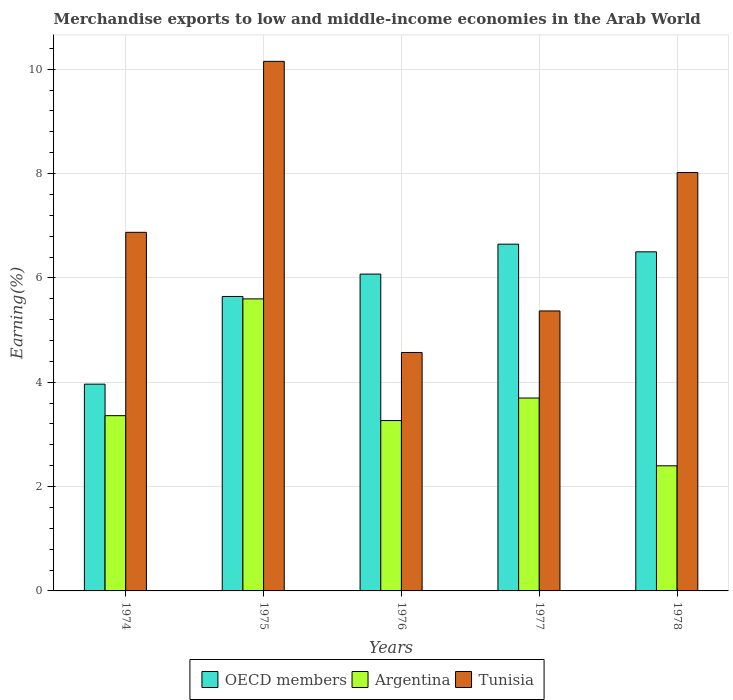How many groups of bars are there?
Your answer should be compact. 5. Are the number of bars on each tick of the X-axis equal?
Provide a short and direct response. Yes. How many bars are there on the 4th tick from the left?
Give a very brief answer. 3. What is the label of the 5th group of bars from the left?
Make the answer very short. 1978. What is the percentage of amount earned from merchandise exports in Argentina in 1977?
Your answer should be very brief. 3.7. Across all years, what is the maximum percentage of amount earned from merchandise exports in Argentina?
Your answer should be compact. 5.6. Across all years, what is the minimum percentage of amount earned from merchandise exports in OECD members?
Your answer should be very brief. 3.96. In which year was the percentage of amount earned from merchandise exports in Tunisia maximum?
Your answer should be compact. 1975. In which year was the percentage of amount earned from merchandise exports in Tunisia minimum?
Offer a very short reply. 1976. What is the total percentage of amount earned from merchandise exports in Tunisia in the graph?
Your answer should be compact. 34.98. What is the difference between the percentage of amount earned from merchandise exports in Argentina in 1977 and that in 1978?
Provide a succinct answer. 1.3. What is the difference between the percentage of amount earned from merchandise exports in OECD members in 1977 and the percentage of amount earned from merchandise exports in Argentina in 1976?
Provide a short and direct response. 3.38. What is the average percentage of amount earned from merchandise exports in Argentina per year?
Provide a short and direct response. 3.66. In the year 1977, what is the difference between the percentage of amount earned from merchandise exports in Argentina and percentage of amount earned from merchandise exports in OECD members?
Your response must be concise. -2.95. What is the ratio of the percentage of amount earned from merchandise exports in Argentina in 1974 to that in 1978?
Make the answer very short. 1.4. Is the percentage of amount earned from merchandise exports in Argentina in 1976 less than that in 1978?
Offer a terse response. No. What is the difference between the highest and the second highest percentage of amount earned from merchandise exports in Argentina?
Keep it short and to the point. 1.9. What is the difference between the highest and the lowest percentage of amount earned from merchandise exports in OECD members?
Offer a very short reply. 2.68. What does the 2nd bar from the left in 1978 represents?
Make the answer very short. Argentina. How many years are there in the graph?
Offer a very short reply. 5. Are the values on the major ticks of Y-axis written in scientific E-notation?
Your response must be concise. No. Does the graph contain grids?
Offer a terse response. Yes. How are the legend labels stacked?
Provide a short and direct response. Horizontal. What is the title of the graph?
Provide a short and direct response. Merchandise exports to low and middle-income economies in the Arab World. Does "Aruba" appear as one of the legend labels in the graph?
Keep it short and to the point. No. What is the label or title of the X-axis?
Your response must be concise. Years. What is the label or title of the Y-axis?
Your answer should be very brief. Earning(%). What is the Earning(%) in OECD members in 1974?
Your answer should be compact. 3.96. What is the Earning(%) of Argentina in 1974?
Provide a succinct answer. 3.36. What is the Earning(%) of Tunisia in 1974?
Ensure brevity in your answer.  6.87. What is the Earning(%) in OECD members in 1975?
Your answer should be compact. 5.64. What is the Earning(%) in Argentina in 1975?
Make the answer very short. 5.6. What is the Earning(%) of Tunisia in 1975?
Give a very brief answer. 10.15. What is the Earning(%) of OECD members in 1976?
Offer a very short reply. 6.07. What is the Earning(%) in Argentina in 1976?
Provide a succinct answer. 3.27. What is the Earning(%) in Tunisia in 1976?
Your answer should be very brief. 4.57. What is the Earning(%) in OECD members in 1977?
Provide a short and direct response. 6.65. What is the Earning(%) of Argentina in 1977?
Offer a terse response. 3.7. What is the Earning(%) in Tunisia in 1977?
Keep it short and to the point. 5.37. What is the Earning(%) of OECD members in 1978?
Provide a short and direct response. 6.5. What is the Earning(%) of Argentina in 1978?
Your response must be concise. 2.4. What is the Earning(%) in Tunisia in 1978?
Your response must be concise. 8.02. Across all years, what is the maximum Earning(%) in OECD members?
Make the answer very short. 6.65. Across all years, what is the maximum Earning(%) in Argentina?
Your response must be concise. 5.6. Across all years, what is the maximum Earning(%) of Tunisia?
Make the answer very short. 10.15. Across all years, what is the minimum Earning(%) in OECD members?
Keep it short and to the point. 3.96. Across all years, what is the minimum Earning(%) in Argentina?
Offer a terse response. 2.4. Across all years, what is the minimum Earning(%) in Tunisia?
Provide a succinct answer. 4.57. What is the total Earning(%) in OECD members in the graph?
Your response must be concise. 28.83. What is the total Earning(%) of Argentina in the graph?
Keep it short and to the point. 18.32. What is the total Earning(%) of Tunisia in the graph?
Provide a succinct answer. 34.98. What is the difference between the Earning(%) in OECD members in 1974 and that in 1975?
Keep it short and to the point. -1.68. What is the difference between the Earning(%) in Argentina in 1974 and that in 1975?
Provide a succinct answer. -2.24. What is the difference between the Earning(%) of Tunisia in 1974 and that in 1975?
Offer a terse response. -3.28. What is the difference between the Earning(%) in OECD members in 1974 and that in 1976?
Offer a terse response. -2.11. What is the difference between the Earning(%) in Argentina in 1974 and that in 1976?
Keep it short and to the point. 0.09. What is the difference between the Earning(%) of Tunisia in 1974 and that in 1976?
Provide a short and direct response. 2.3. What is the difference between the Earning(%) of OECD members in 1974 and that in 1977?
Ensure brevity in your answer.  -2.68. What is the difference between the Earning(%) of Argentina in 1974 and that in 1977?
Make the answer very short. -0.34. What is the difference between the Earning(%) of Tunisia in 1974 and that in 1977?
Ensure brevity in your answer.  1.51. What is the difference between the Earning(%) of OECD members in 1974 and that in 1978?
Provide a short and direct response. -2.54. What is the difference between the Earning(%) of Argentina in 1974 and that in 1978?
Your answer should be very brief. 0.96. What is the difference between the Earning(%) in Tunisia in 1974 and that in 1978?
Provide a short and direct response. -1.15. What is the difference between the Earning(%) of OECD members in 1975 and that in 1976?
Offer a very short reply. -0.43. What is the difference between the Earning(%) in Argentina in 1975 and that in 1976?
Ensure brevity in your answer.  2.33. What is the difference between the Earning(%) in Tunisia in 1975 and that in 1976?
Give a very brief answer. 5.58. What is the difference between the Earning(%) of OECD members in 1975 and that in 1977?
Offer a very short reply. -1. What is the difference between the Earning(%) of Argentina in 1975 and that in 1977?
Offer a terse response. 1.9. What is the difference between the Earning(%) in Tunisia in 1975 and that in 1977?
Provide a succinct answer. 4.78. What is the difference between the Earning(%) in OECD members in 1975 and that in 1978?
Your answer should be very brief. -0.86. What is the difference between the Earning(%) of Argentina in 1975 and that in 1978?
Keep it short and to the point. 3.2. What is the difference between the Earning(%) of Tunisia in 1975 and that in 1978?
Make the answer very short. 2.13. What is the difference between the Earning(%) of OECD members in 1976 and that in 1977?
Offer a terse response. -0.57. What is the difference between the Earning(%) in Argentina in 1976 and that in 1977?
Keep it short and to the point. -0.43. What is the difference between the Earning(%) in Tunisia in 1976 and that in 1977?
Offer a terse response. -0.8. What is the difference between the Earning(%) of OECD members in 1976 and that in 1978?
Give a very brief answer. -0.43. What is the difference between the Earning(%) in Argentina in 1976 and that in 1978?
Offer a terse response. 0.87. What is the difference between the Earning(%) in Tunisia in 1976 and that in 1978?
Your response must be concise. -3.45. What is the difference between the Earning(%) of OECD members in 1977 and that in 1978?
Offer a terse response. 0.15. What is the difference between the Earning(%) of Argentina in 1977 and that in 1978?
Provide a succinct answer. 1.3. What is the difference between the Earning(%) of Tunisia in 1977 and that in 1978?
Keep it short and to the point. -2.65. What is the difference between the Earning(%) of OECD members in 1974 and the Earning(%) of Argentina in 1975?
Offer a very short reply. -1.63. What is the difference between the Earning(%) in OECD members in 1974 and the Earning(%) in Tunisia in 1975?
Your response must be concise. -6.19. What is the difference between the Earning(%) in Argentina in 1974 and the Earning(%) in Tunisia in 1975?
Your answer should be very brief. -6.79. What is the difference between the Earning(%) in OECD members in 1974 and the Earning(%) in Argentina in 1976?
Your answer should be very brief. 0.7. What is the difference between the Earning(%) in OECD members in 1974 and the Earning(%) in Tunisia in 1976?
Your answer should be very brief. -0.61. What is the difference between the Earning(%) in Argentina in 1974 and the Earning(%) in Tunisia in 1976?
Your answer should be very brief. -1.21. What is the difference between the Earning(%) in OECD members in 1974 and the Earning(%) in Argentina in 1977?
Ensure brevity in your answer.  0.27. What is the difference between the Earning(%) of OECD members in 1974 and the Earning(%) of Tunisia in 1977?
Your answer should be very brief. -1.4. What is the difference between the Earning(%) of Argentina in 1974 and the Earning(%) of Tunisia in 1977?
Ensure brevity in your answer.  -2.01. What is the difference between the Earning(%) in OECD members in 1974 and the Earning(%) in Argentina in 1978?
Your answer should be compact. 1.56. What is the difference between the Earning(%) in OECD members in 1974 and the Earning(%) in Tunisia in 1978?
Offer a very short reply. -4.06. What is the difference between the Earning(%) in Argentina in 1974 and the Earning(%) in Tunisia in 1978?
Give a very brief answer. -4.66. What is the difference between the Earning(%) in OECD members in 1975 and the Earning(%) in Argentina in 1976?
Provide a succinct answer. 2.38. What is the difference between the Earning(%) of OECD members in 1975 and the Earning(%) of Tunisia in 1976?
Provide a short and direct response. 1.07. What is the difference between the Earning(%) in OECD members in 1975 and the Earning(%) in Argentina in 1977?
Your response must be concise. 1.95. What is the difference between the Earning(%) of OECD members in 1975 and the Earning(%) of Tunisia in 1977?
Provide a succinct answer. 0.28. What is the difference between the Earning(%) of Argentina in 1975 and the Earning(%) of Tunisia in 1977?
Offer a very short reply. 0.23. What is the difference between the Earning(%) of OECD members in 1975 and the Earning(%) of Argentina in 1978?
Your answer should be compact. 3.25. What is the difference between the Earning(%) in OECD members in 1975 and the Earning(%) in Tunisia in 1978?
Provide a short and direct response. -2.38. What is the difference between the Earning(%) of Argentina in 1975 and the Earning(%) of Tunisia in 1978?
Your response must be concise. -2.42. What is the difference between the Earning(%) of OECD members in 1976 and the Earning(%) of Argentina in 1977?
Provide a short and direct response. 2.38. What is the difference between the Earning(%) of OECD members in 1976 and the Earning(%) of Tunisia in 1977?
Offer a terse response. 0.71. What is the difference between the Earning(%) in Argentina in 1976 and the Earning(%) in Tunisia in 1977?
Give a very brief answer. -2.1. What is the difference between the Earning(%) of OECD members in 1976 and the Earning(%) of Argentina in 1978?
Offer a terse response. 3.67. What is the difference between the Earning(%) in OECD members in 1976 and the Earning(%) in Tunisia in 1978?
Offer a very short reply. -1.95. What is the difference between the Earning(%) of Argentina in 1976 and the Earning(%) of Tunisia in 1978?
Ensure brevity in your answer.  -4.75. What is the difference between the Earning(%) of OECD members in 1977 and the Earning(%) of Argentina in 1978?
Your response must be concise. 4.25. What is the difference between the Earning(%) of OECD members in 1977 and the Earning(%) of Tunisia in 1978?
Provide a succinct answer. -1.37. What is the difference between the Earning(%) of Argentina in 1977 and the Earning(%) of Tunisia in 1978?
Keep it short and to the point. -4.32. What is the average Earning(%) in OECD members per year?
Your response must be concise. 5.77. What is the average Earning(%) in Argentina per year?
Make the answer very short. 3.66. What is the average Earning(%) of Tunisia per year?
Give a very brief answer. 7. In the year 1974, what is the difference between the Earning(%) of OECD members and Earning(%) of Argentina?
Give a very brief answer. 0.6. In the year 1974, what is the difference between the Earning(%) in OECD members and Earning(%) in Tunisia?
Provide a short and direct response. -2.91. In the year 1974, what is the difference between the Earning(%) in Argentina and Earning(%) in Tunisia?
Keep it short and to the point. -3.51. In the year 1975, what is the difference between the Earning(%) of OECD members and Earning(%) of Argentina?
Give a very brief answer. 0.05. In the year 1975, what is the difference between the Earning(%) of OECD members and Earning(%) of Tunisia?
Give a very brief answer. -4.51. In the year 1975, what is the difference between the Earning(%) in Argentina and Earning(%) in Tunisia?
Ensure brevity in your answer.  -4.55. In the year 1976, what is the difference between the Earning(%) in OECD members and Earning(%) in Argentina?
Provide a succinct answer. 2.81. In the year 1976, what is the difference between the Earning(%) of OECD members and Earning(%) of Tunisia?
Your answer should be very brief. 1.5. In the year 1976, what is the difference between the Earning(%) of Argentina and Earning(%) of Tunisia?
Your answer should be very brief. -1.3. In the year 1977, what is the difference between the Earning(%) in OECD members and Earning(%) in Argentina?
Provide a short and direct response. 2.95. In the year 1977, what is the difference between the Earning(%) in OECD members and Earning(%) in Tunisia?
Your answer should be very brief. 1.28. In the year 1977, what is the difference between the Earning(%) in Argentina and Earning(%) in Tunisia?
Offer a terse response. -1.67. In the year 1978, what is the difference between the Earning(%) of OECD members and Earning(%) of Argentina?
Provide a short and direct response. 4.1. In the year 1978, what is the difference between the Earning(%) of OECD members and Earning(%) of Tunisia?
Give a very brief answer. -1.52. In the year 1978, what is the difference between the Earning(%) in Argentina and Earning(%) in Tunisia?
Offer a very short reply. -5.62. What is the ratio of the Earning(%) in OECD members in 1974 to that in 1975?
Keep it short and to the point. 0.7. What is the ratio of the Earning(%) of Argentina in 1974 to that in 1975?
Keep it short and to the point. 0.6. What is the ratio of the Earning(%) in Tunisia in 1974 to that in 1975?
Offer a terse response. 0.68. What is the ratio of the Earning(%) in OECD members in 1974 to that in 1976?
Provide a short and direct response. 0.65. What is the ratio of the Earning(%) in Argentina in 1974 to that in 1976?
Keep it short and to the point. 1.03. What is the ratio of the Earning(%) in Tunisia in 1974 to that in 1976?
Your answer should be very brief. 1.5. What is the ratio of the Earning(%) of OECD members in 1974 to that in 1977?
Give a very brief answer. 0.6. What is the ratio of the Earning(%) of Argentina in 1974 to that in 1977?
Your response must be concise. 0.91. What is the ratio of the Earning(%) of Tunisia in 1974 to that in 1977?
Ensure brevity in your answer.  1.28. What is the ratio of the Earning(%) in OECD members in 1974 to that in 1978?
Provide a succinct answer. 0.61. What is the ratio of the Earning(%) in Argentina in 1974 to that in 1978?
Offer a terse response. 1.4. What is the ratio of the Earning(%) of Tunisia in 1974 to that in 1978?
Make the answer very short. 0.86. What is the ratio of the Earning(%) of OECD members in 1975 to that in 1976?
Provide a short and direct response. 0.93. What is the ratio of the Earning(%) of Argentina in 1975 to that in 1976?
Give a very brief answer. 1.71. What is the ratio of the Earning(%) in Tunisia in 1975 to that in 1976?
Give a very brief answer. 2.22. What is the ratio of the Earning(%) of OECD members in 1975 to that in 1977?
Provide a succinct answer. 0.85. What is the ratio of the Earning(%) in Argentina in 1975 to that in 1977?
Provide a succinct answer. 1.51. What is the ratio of the Earning(%) of Tunisia in 1975 to that in 1977?
Make the answer very short. 1.89. What is the ratio of the Earning(%) of OECD members in 1975 to that in 1978?
Offer a very short reply. 0.87. What is the ratio of the Earning(%) of Argentina in 1975 to that in 1978?
Your response must be concise. 2.33. What is the ratio of the Earning(%) in Tunisia in 1975 to that in 1978?
Provide a succinct answer. 1.27. What is the ratio of the Earning(%) in OECD members in 1976 to that in 1977?
Give a very brief answer. 0.91. What is the ratio of the Earning(%) of Argentina in 1976 to that in 1977?
Your answer should be compact. 0.88. What is the ratio of the Earning(%) in Tunisia in 1976 to that in 1977?
Your response must be concise. 0.85. What is the ratio of the Earning(%) in OECD members in 1976 to that in 1978?
Ensure brevity in your answer.  0.93. What is the ratio of the Earning(%) in Argentina in 1976 to that in 1978?
Keep it short and to the point. 1.36. What is the ratio of the Earning(%) in Tunisia in 1976 to that in 1978?
Your answer should be very brief. 0.57. What is the ratio of the Earning(%) in OECD members in 1977 to that in 1978?
Offer a very short reply. 1.02. What is the ratio of the Earning(%) in Argentina in 1977 to that in 1978?
Ensure brevity in your answer.  1.54. What is the ratio of the Earning(%) in Tunisia in 1977 to that in 1978?
Offer a terse response. 0.67. What is the difference between the highest and the second highest Earning(%) of OECD members?
Ensure brevity in your answer.  0.15. What is the difference between the highest and the second highest Earning(%) of Argentina?
Keep it short and to the point. 1.9. What is the difference between the highest and the second highest Earning(%) of Tunisia?
Keep it short and to the point. 2.13. What is the difference between the highest and the lowest Earning(%) in OECD members?
Provide a short and direct response. 2.68. What is the difference between the highest and the lowest Earning(%) of Argentina?
Your answer should be very brief. 3.2. What is the difference between the highest and the lowest Earning(%) in Tunisia?
Offer a very short reply. 5.58. 